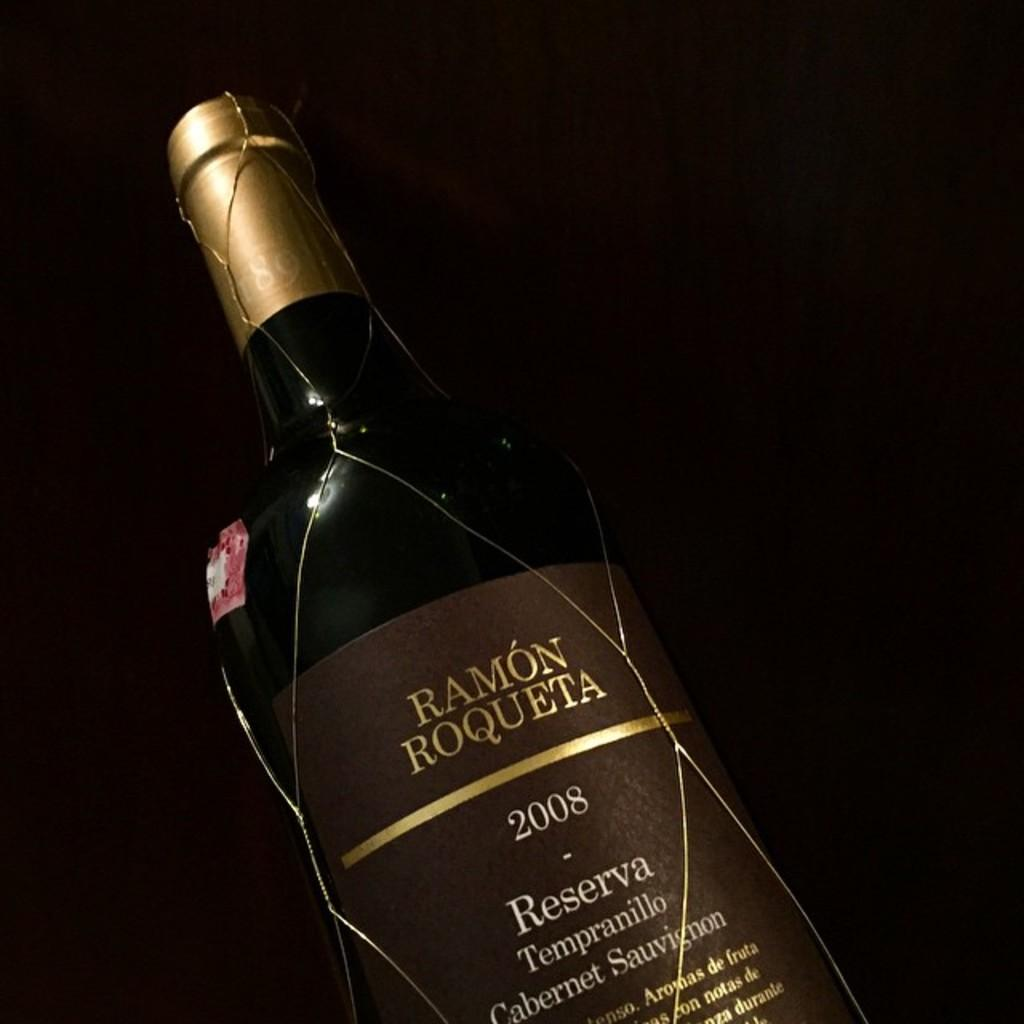<image>
Describe the image concisely. A bottle of Ramon Roqueta from 2008 has gold wires wrapping it. 